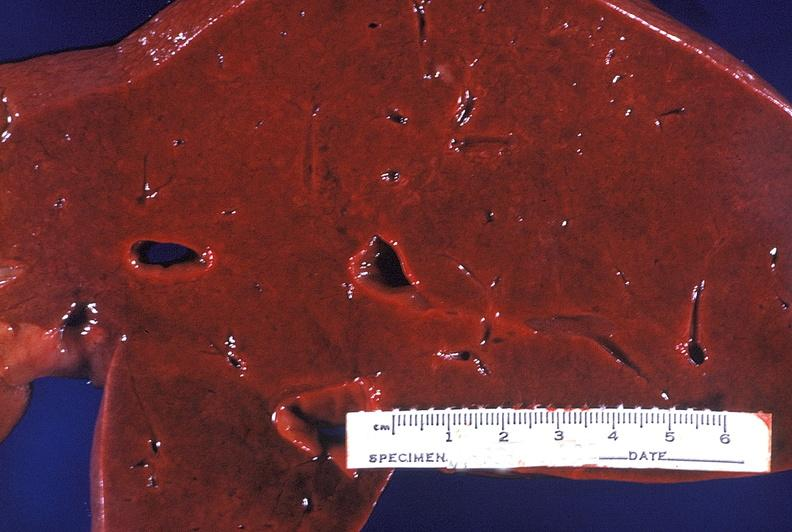s syndactyly present?
Answer the question using a single word or phrase. No 